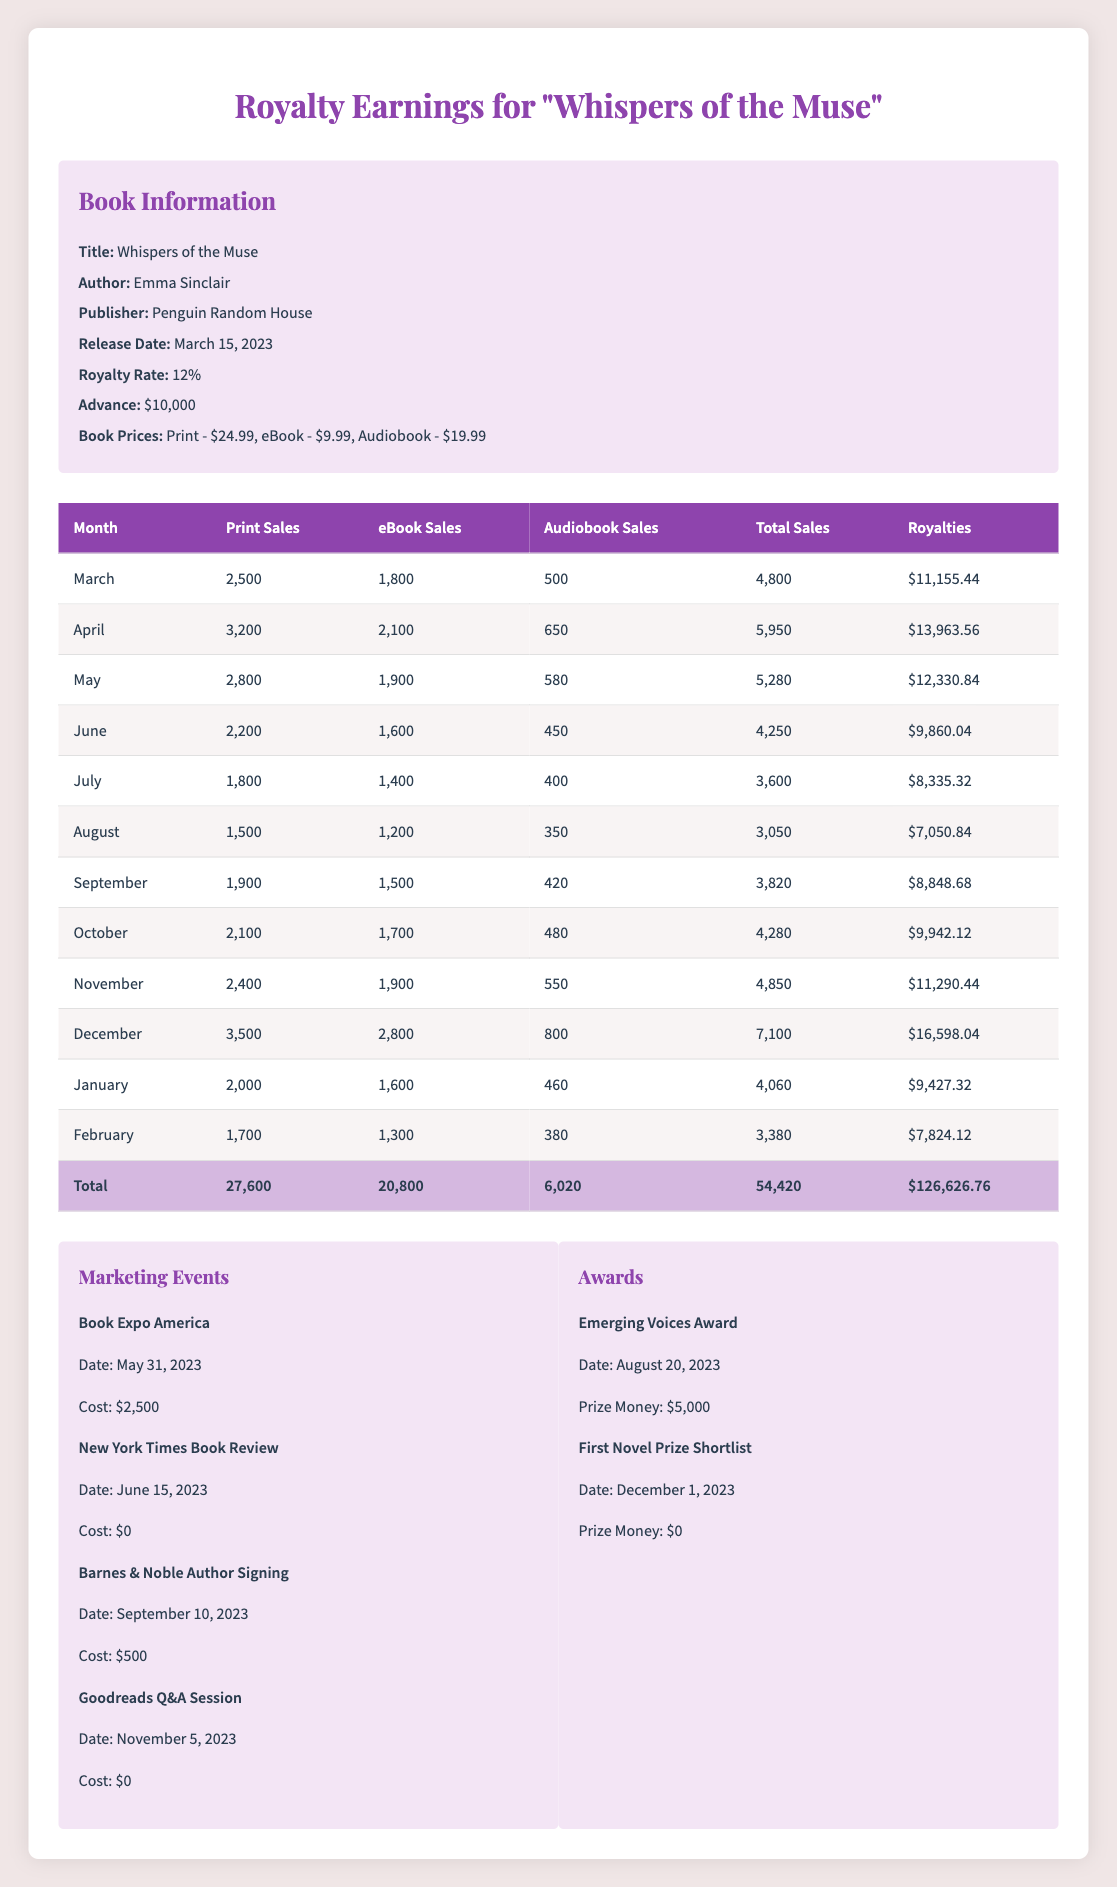What was the total number of print sales for the debut novel "Whispers of the Muse" over the year? By summing the print sales from each month: 2500 + 3200 + 2800 + 2200 + 1800 + 1500 + 1900 + 2100 + 2400 + 3500 + 2000 + 1700 = 27,600.
Answer: 27,600 What were the total ebook sales in the first year? Adding the ebook sales from each month: 1800 + 2100 + 1900 + 1600 + 1400 + 1200 + 1500 + 1700 + 1900 + 2800 + 1600 + 1300 = 20,800.
Answer: 20,800 Did "Whispers of the Muse" receive any prize money for awards? Yes, it did receive prize money from the "Emerging Voices Award" totaling 5000, while the "First Novel Prize Shortlist" did not offer any prize money.
Answer: Yes What was the highest month of royalty earnings for the novel? The highest royalty occurred in December with earnings of 16,598.04 based on the monthly sales calculations.
Answer: 16,598.04 What is the average monthly print sales for the first year? The average can be calculated by taking the total print sales of 27,600 and dividing by 12 months, which equals 2,300.
Answer: 2,300 How much did the author spend on marketing events? The costs for marketing events are: 2500 (Book Expo America) + 0 (New York Times Book Review) + 500 (Barnes & Noble Author Signing) + 0 (Goodreads Q&A Session) = 3000.
Answer: 3,000 Is the total royalty amount equal to or greater than the advance the author received? Yes, the total royalties amount of 126,626.76 is significantly greater than the advance of 10,000.
Answer: Yes What was the average royalty earned per month for the year? The total royalties of 126,626.76 divided by the 12 months gives an average of 10,552.23 for each month.
Answer: 10,552.23 Which month had the lowest total sales? The month of August had the lowest total sales at 3050, compared to all other months.
Answer: 3050 What was the overall profit from the book, considering the advance and marketing costs? Profit can be calculated as total earnings (126,626.76) minus the advance (10,000) and marketing costs (3000), equaling 113,626.76.
Answer: 113,626.76 